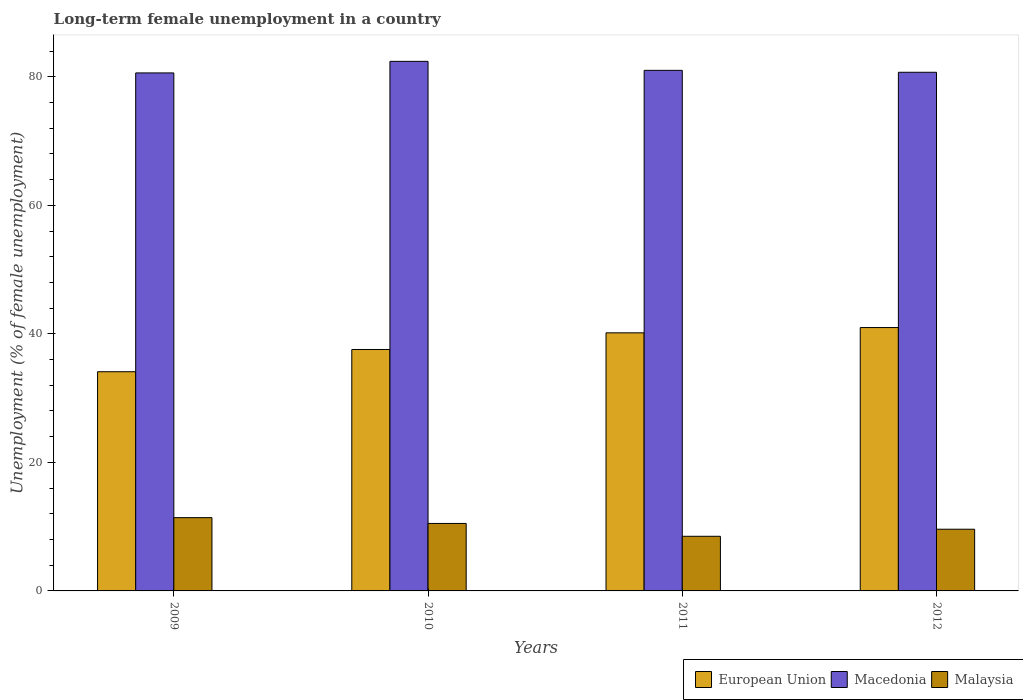How many different coloured bars are there?
Your response must be concise. 3. How many groups of bars are there?
Make the answer very short. 4. Are the number of bars per tick equal to the number of legend labels?
Your answer should be compact. Yes. Are the number of bars on each tick of the X-axis equal?
Your answer should be compact. Yes. How many bars are there on the 2nd tick from the left?
Your answer should be compact. 3. How many bars are there on the 3rd tick from the right?
Offer a terse response. 3. What is the label of the 2nd group of bars from the left?
Your answer should be compact. 2010. In how many cases, is the number of bars for a given year not equal to the number of legend labels?
Provide a succinct answer. 0. Across all years, what is the maximum percentage of long-term unemployed female population in Macedonia?
Provide a short and direct response. 82.4. Across all years, what is the minimum percentage of long-term unemployed female population in Macedonia?
Provide a succinct answer. 80.6. In which year was the percentage of long-term unemployed female population in European Union minimum?
Provide a succinct answer. 2009. What is the total percentage of long-term unemployed female population in Malaysia in the graph?
Keep it short and to the point. 40. What is the difference between the percentage of long-term unemployed female population in Malaysia in 2009 and that in 2012?
Keep it short and to the point. 1.8. What is the difference between the percentage of long-term unemployed female population in European Union in 2011 and the percentage of long-term unemployed female population in Malaysia in 2010?
Provide a succinct answer. 29.66. What is the average percentage of long-term unemployed female population in Macedonia per year?
Provide a short and direct response. 81.17. In the year 2011, what is the difference between the percentage of long-term unemployed female population in Malaysia and percentage of long-term unemployed female population in European Union?
Your answer should be compact. -31.66. In how many years, is the percentage of long-term unemployed female population in European Union greater than 8 %?
Your answer should be compact. 4. What is the ratio of the percentage of long-term unemployed female population in Malaysia in 2010 to that in 2011?
Your response must be concise. 1.24. What is the difference between the highest and the second highest percentage of long-term unemployed female population in Malaysia?
Your answer should be very brief. 0.9. What is the difference between the highest and the lowest percentage of long-term unemployed female population in Malaysia?
Make the answer very short. 2.9. Is the sum of the percentage of long-term unemployed female population in Malaysia in 2009 and 2012 greater than the maximum percentage of long-term unemployed female population in Macedonia across all years?
Provide a short and direct response. No. What does the 3rd bar from the left in 2012 represents?
Offer a terse response. Malaysia. What does the 2nd bar from the right in 2009 represents?
Your response must be concise. Macedonia. Is it the case that in every year, the sum of the percentage of long-term unemployed female population in Malaysia and percentage of long-term unemployed female population in Macedonia is greater than the percentage of long-term unemployed female population in European Union?
Your answer should be very brief. Yes. Are all the bars in the graph horizontal?
Ensure brevity in your answer.  No. What is the difference between two consecutive major ticks on the Y-axis?
Your answer should be compact. 20. Does the graph contain any zero values?
Your answer should be very brief. No. Does the graph contain grids?
Ensure brevity in your answer.  No. Where does the legend appear in the graph?
Offer a very short reply. Bottom right. How many legend labels are there?
Ensure brevity in your answer.  3. What is the title of the graph?
Your answer should be very brief. Long-term female unemployment in a country. What is the label or title of the X-axis?
Keep it short and to the point. Years. What is the label or title of the Y-axis?
Ensure brevity in your answer.  Unemployment (% of female unemployment). What is the Unemployment (% of female unemployment) in European Union in 2009?
Provide a succinct answer. 34.11. What is the Unemployment (% of female unemployment) in Macedonia in 2009?
Offer a very short reply. 80.6. What is the Unemployment (% of female unemployment) of Malaysia in 2009?
Offer a very short reply. 11.4. What is the Unemployment (% of female unemployment) of European Union in 2010?
Offer a very short reply. 37.57. What is the Unemployment (% of female unemployment) of Macedonia in 2010?
Make the answer very short. 82.4. What is the Unemployment (% of female unemployment) of Malaysia in 2010?
Offer a terse response. 10.5. What is the Unemployment (% of female unemployment) of European Union in 2011?
Give a very brief answer. 40.16. What is the Unemployment (% of female unemployment) of Malaysia in 2011?
Ensure brevity in your answer.  8.5. What is the Unemployment (% of female unemployment) in European Union in 2012?
Give a very brief answer. 40.98. What is the Unemployment (% of female unemployment) of Macedonia in 2012?
Offer a terse response. 80.7. What is the Unemployment (% of female unemployment) of Malaysia in 2012?
Provide a short and direct response. 9.6. Across all years, what is the maximum Unemployment (% of female unemployment) of European Union?
Give a very brief answer. 40.98. Across all years, what is the maximum Unemployment (% of female unemployment) of Macedonia?
Offer a terse response. 82.4. Across all years, what is the maximum Unemployment (% of female unemployment) of Malaysia?
Offer a very short reply. 11.4. Across all years, what is the minimum Unemployment (% of female unemployment) of European Union?
Provide a succinct answer. 34.11. Across all years, what is the minimum Unemployment (% of female unemployment) in Macedonia?
Your answer should be compact. 80.6. Across all years, what is the minimum Unemployment (% of female unemployment) of Malaysia?
Keep it short and to the point. 8.5. What is the total Unemployment (% of female unemployment) in European Union in the graph?
Provide a short and direct response. 152.81. What is the total Unemployment (% of female unemployment) in Macedonia in the graph?
Your answer should be compact. 324.7. What is the difference between the Unemployment (% of female unemployment) of European Union in 2009 and that in 2010?
Provide a succinct answer. -3.46. What is the difference between the Unemployment (% of female unemployment) in Malaysia in 2009 and that in 2010?
Your answer should be compact. 0.9. What is the difference between the Unemployment (% of female unemployment) in European Union in 2009 and that in 2011?
Provide a succinct answer. -6.05. What is the difference between the Unemployment (% of female unemployment) of Macedonia in 2009 and that in 2011?
Ensure brevity in your answer.  -0.4. What is the difference between the Unemployment (% of female unemployment) of European Union in 2009 and that in 2012?
Make the answer very short. -6.87. What is the difference between the Unemployment (% of female unemployment) of Macedonia in 2009 and that in 2012?
Make the answer very short. -0.1. What is the difference between the Unemployment (% of female unemployment) in European Union in 2010 and that in 2011?
Your answer should be compact. -2.59. What is the difference between the Unemployment (% of female unemployment) of Macedonia in 2010 and that in 2011?
Make the answer very short. 1.4. What is the difference between the Unemployment (% of female unemployment) in Malaysia in 2010 and that in 2011?
Provide a succinct answer. 2. What is the difference between the Unemployment (% of female unemployment) in European Union in 2010 and that in 2012?
Provide a short and direct response. -3.41. What is the difference between the Unemployment (% of female unemployment) in Macedonia in 2010 and that in 2012?
Your response must be concise. 1.7. What is the difference between the Unemployment (% of female unemployment) of European Union in 2011 and that in 2012?
Your response must be concise. -0.82. What is the difference between the Unemployment (% of female unemployment) of Macedonia in 2011 and that in 2012?
Provide a succinct answer. 0.3. What is the difference between the Unemployment (% of female unemployment) in Malaysia in 2011 and that in 2012?
Your answer should be compact. -1.1. What is the difference between the Unemployment (% of female unemployment) in European Union in 2009 and the Unemployment (% of female unemployment) in Macedonia in 2010?
Ensure brevity in your answer.  -48.29. What is the difference between the Unemployment (% of female unemployment) of European Union in 2009 and the Unemployment (% of female unemployment) of Malaysia in 2010?
Provide a succinct answer. 23.61. What is the difference between the Unemployment (% of female unemployment) of Macedonia in 2009 and the Unemployment (% of female unemployment) of Malaysia in 2010?
Your answer should be compact. 70.1. What is the difference between the Unemployment (% of female unemployment) of European Union in 2009 and the Unemployment (% of female unemployment) of Macedonia in 2011?
Your answer should be very brief. -46.89. What is the difference between the Unemployment (% of female unemployment) of European Union in 2009 and the Unemployment (% of female unemployment) of Malaysia in 2011?
Make the answer very short. 25.61. What is the difference between the Unemployment (% of female unemployment) of Macedonia in 2009 and the Unemployment (% of female unemployment) of Malaysia in 2011?
Offer a terse response. 72.1. What is the difference between the Unemployment (% of female unemployment) of European Union in 2009 and the Unemployment (% of female unemployment) of Macedonia in 2012?
Your answer should be very brief. -46.59. What is the difference between the Unemployment (% of female unemployment) in European Union in 2009 and the Unemployment (% of female unemployment) in Malaysia in 2012?
Offer a terse response. 24.51. What is the difference between the Unemployment (% of female unemployment) in European Union in 2010 and the Unemployment (% of female unemployment) in Macedonia in 2011?
Your response must be concise. -43.43. What is the difference between the Unemployment (% of female unemployment) of European Union in 2010 and the Unemployment (% of female unemployment) of Malaysia in 2011?
Your answer should be compact. 29.07. What is the difference between the Unemployment (% of female unemployment) of Macedonia in 2010 and the Unemployment (% of female unemployment) of Malaysia in 2011?
Make the answer very short. 73.9. What is the difference between the Unemployment (% of female unemployment) of European Union in 2010 and the Unemployment (% of female unemployment) of Macedonia in 2012?
Your response must be concise. -43.13. What is the difference between the Unemployment (% of female unemployment) of European Union in 2010 and the Unemployment (% of female unemployment) of Malaysia in 2012?
Offer a very short reply. 27.97. What is the difference between the Unemployment (% of female unemployment) in Macedonia in 2010 and the Unemployment (% of female unemployment) in Malaysia in 2012?
Offer a terse response. 72.8. What is the difference between the Unemployment (% of female unemployment) in European Union in 2011 and the Unemployment (% of female unemployment) in Macedonia in 2012?
Ensure brevity in your answer.  -40.54. What is the difference between the Unemployment (% of female unemployment) in European Union in 2011 and the Unemployment (% of female unemployment) in Malaysia in 2012?
Offer a terse response. 30.56. What is the difference between the Unemployment (% of female unemployment) in Macedonia in 2011 and the Unemployment (% of female unemployment) in Malaysia in 2012?
Offer a terse response. 71.4. What is the average Unemployment (% of female unemployment) in European Union per year?
Offer a very short reply. 38.2. What is the average Unemployment (% of female unemployment) of Macedonia per year?
Give a very brief answer. 81.17. In the year 2009, what is the difference between the Unemployment (% of female unemployment) of European Union and Unemployment (% of female unemployment) of Macedonia?
Ensure brevity in your answer.  -46.49. In the year 2009, what is the difference between the Unemployment (% of female unemployment) in European Union and Unemployment (% of female unemployment) in Malaysia?
Your answer should be very brief. 22.71. In the year 2009, what is the difference between the Unemployment (% of female unemployment) in Macedonia and Unemployment (% of female unemployment) in Malaysia?
Offer a terse response. 69.2. In the year 2010, what is the difference between the Unemployment (% of female unemployment) of European Union and Unemployment (% of female unemployment) of Macedonia?
Keep it short and to the point. -44.83. In the year 2010, what is the difference between the Unemployment (% of female unemployment) in European Union and Unemployment (% of female unemployment) in Malaysia?
Offer a very short reply. 27.07. In the year 2010, what is the difference between the Unemployment (% of female unemployment) in Macedonia and Unemployment (% of female unemployment) in Malaysia?
Provide a succinct answer. 71.9. In the year 2011, what is the difference between the Unemployment (% of female unemployment) in European Union and Unemployment (% of female unemployment) in Macedonia?
Your answer should be very brief. -40.84. In the year 2011, what is the difference between the Unemployment (% of female unemployment) of European Union and Unemployment (% of female unemployment) of Malaysia?
Your answer should be very brief. 31.66. In the year 2011, what is the difference between the Unemployment (% of female unemployment) in Macedonia and Unemployment (% of female unemployment) in Malaysia?
Your response must be concise. 72.5. In the year 2012, what is the difference between the Unemployment (% of female unemployment) of European Union and Unemployment (% of female unemployment) of Macedonia?
Your answer should be compact. -39.72. In the year 2012, what is the difference between the Unemployment (% of female unemployment) of European Union and Unemployment (% of female unemployment) of Malaysia?
Your response must be concise. 31.38. In the year 2012, what is the difference between the Unemployment (% of female unemployment) of Macedonia and Unemployment (% of female unemployment) of Malaysia?
Your answer should be very brief. 71.1. What is the ratio of the Unemployment (% of female unemployment) in European Union in 2009 to that in 2010?
Offer a terse response. 0.91. What is the ratio of the Unemployment (% of female unemployment) in Macedonia in 2009 to that in 2010?
Your answer should be compact. 0.98. What is the ratio of the Unemployment (% of female unemployment) of Malaysia in 2009 to that in 2010?
Offer a terse response. 1.09. What is the ratio of the Unemployment (% of female unemployment) of European Union in 2009 to that in 2011?
Your response must be concise. 0.85. What is the ratio of the Unemployment (% of female unemployment) of Macedonia in 2009 to that in 2011?
Your answer should be very brief. 1. What is the ratio of the Unemployment (% of female unemployment) in Malaysia in 2009 to that in 2011?
Make the answer very short. 1.34. What is the ratio of the Unemployment (% of female unemployment) in European Union in 2009 to that in 2012?
Make the answer very short. 0.83. What is the ratio of the Unemployment (% of female unemployment) in Malaysia in 2009 to that in 2012?
Ensure brevity in your answer.  1.19. What is the ratio of the Unemployment (% of female unemployment) of European Union in 2010 to that in 2011?
Make the answer very short. 0.94. What is the ratio of the Unemployment (% of female unemployment) of Macedonia in 2010 to that in 2011?
Your answer should be very brief. 1.02. What is the ratio of the Unemployment (% of female unemployment) in Malaysia in 2010 to that in 2011?
Offer a terse response. 1.24. What is the ratio of the Unemployment (% of female unemployment) in European Union in 2010 to that in 2012?
Make the answer very short. 0.92. What is the ratio of the Unemployment (% of female unemployment) in Macedonia in 2010 to that in 2012?
Keep it short and to the point. 1.02. What is the ratio of the Unemployment (% of female unemployment) in Malaysia in 2010 to that in 2012?
Keep it short and to the point. 1.09. What is the ratio of the Unemployment (% of female unemployment) in European Union in 2011 to that in 2012?
Offer a terse response. 0.98. What is the ratio of the Unemployment (% of female unemployment) of Macedonia in 2011 to that in 2012?
Your response must be concise. 1. What is the ratio of the Unemployment (% of female unemployment) in Malaysia in 2011 to that in 2012?
Ensure brevity in your answer.  0.89. What is the difference between the highest and the second highest Unemployment (% of female unemployment) of European Union?
Keep it short and to the point. 0.82. What is the difference between the highest and the second highest Unemployment (% of female unemployment) of Macedonia?
Provide a short and direct response. 1.4. What is the difference between the highest and the second highest Unemployment (% of female unemployment) in Malaysia?
Keep it short and to the point. 0.9. What is the difference between the highest and the lowest Unemployment (% of female unemployment) in European Union?
Make the answer very short. 6.87. What is the difference between the highest and the lowest Unemployment (% of female unemployment) of Macedonia?
Your response must be concise. 1.8. 